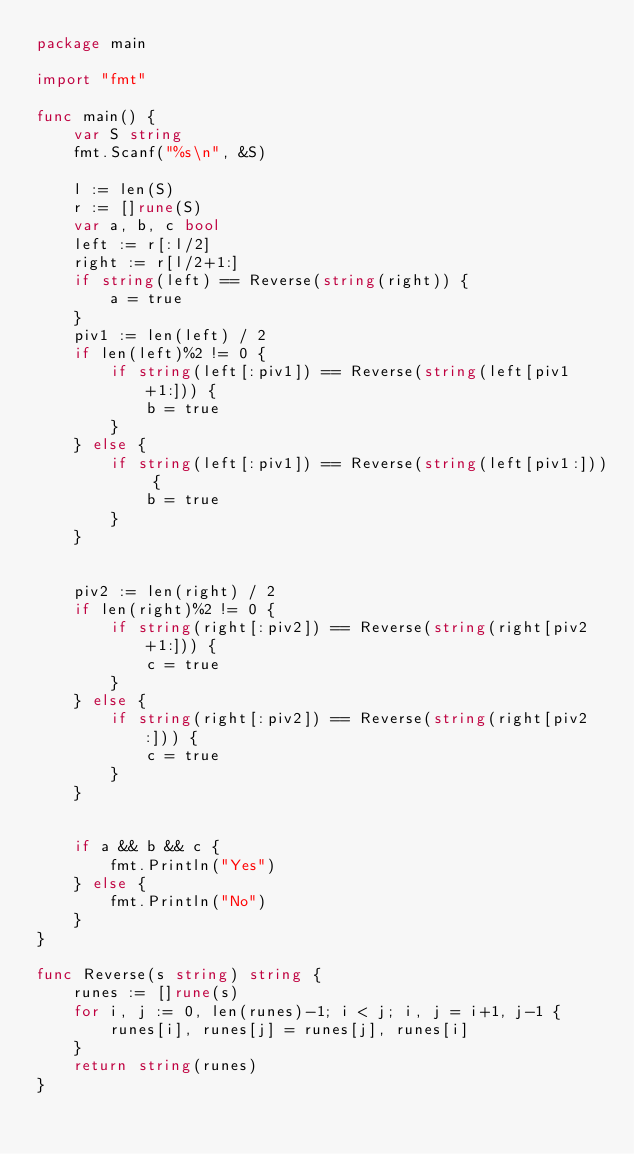Convert code to text. <code><loc_0><loc_0><loc_500><loc_500><_Go_>package main

import "fmt"

func main() {
	var S string
	fmt.Scanf("%s\n", &S)

	l := len(S)
	r := []rune(S)
	var a, b, c bool
	left := r[:l/2]
	right := r[l/2+1:]
	if string(left) == Reverse(string(right)) {
		a = true
	}
	piv1 := len(left) / 2
	if len(left)%2 != 0 {
		if string(left[:piv1]) == Reverse(string(left[piv1+1:])) {
			b = true
		}
    } else {
      	if string(left[:piv1]) == Reverse(string(left[piv1:])) {
			b = true
		}
    }


	piv2 := len(right) / 2
	if len(right)%2 != 0 {
		if string(right[:piv2]) == Reverse(string(right[piv2+1:])) {
			c = true
		}
    } else {
      	if string(right[:piv2]) == Reverse(string(right[piv2:])) {
			c = true
		}
    }


	if a && b && c {
		fmt.Println("Yes")
	} else {
		fmt.Println("No")
	}
}

func Reverse(s string) string {
	runes := []rune(s)
	for i, j := 0, len(runes)-1; i < j; i, j = i+1, j-1 {
		runes[i], runes[j] = runes[j], runes[i]
	}
	return string(runes)
}
</code> 